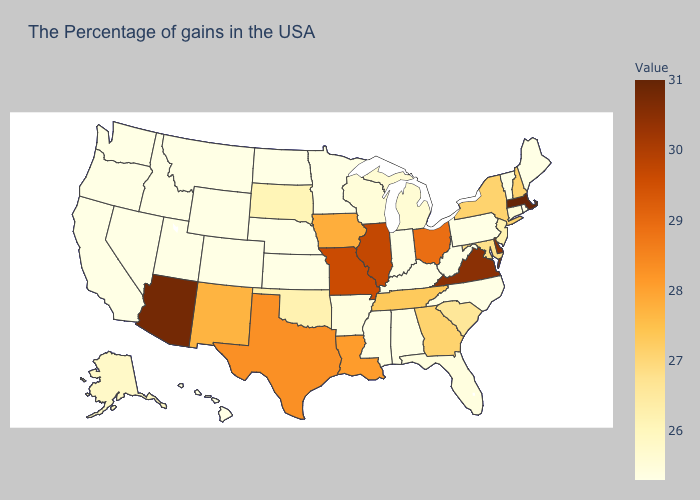Does New York have the highest value in the USA?
Concise answer only. No. Does South Carolina have the highest value in the USA?
Give a very brief answer. No. Among the states that border South Dakota , which have the lowest value?
Write a very short answer. Minnesota, Nebraska, North Dakota, Wyoming, Montana. Does Utah have a higher value than South Carolina?
Answer briefly. No. Does Massachusetts have the highest value in the USA?
Keep it brief. Yes. Among the states that border Arkansas , which have the highest value?
Quick response, please. Missouri. 